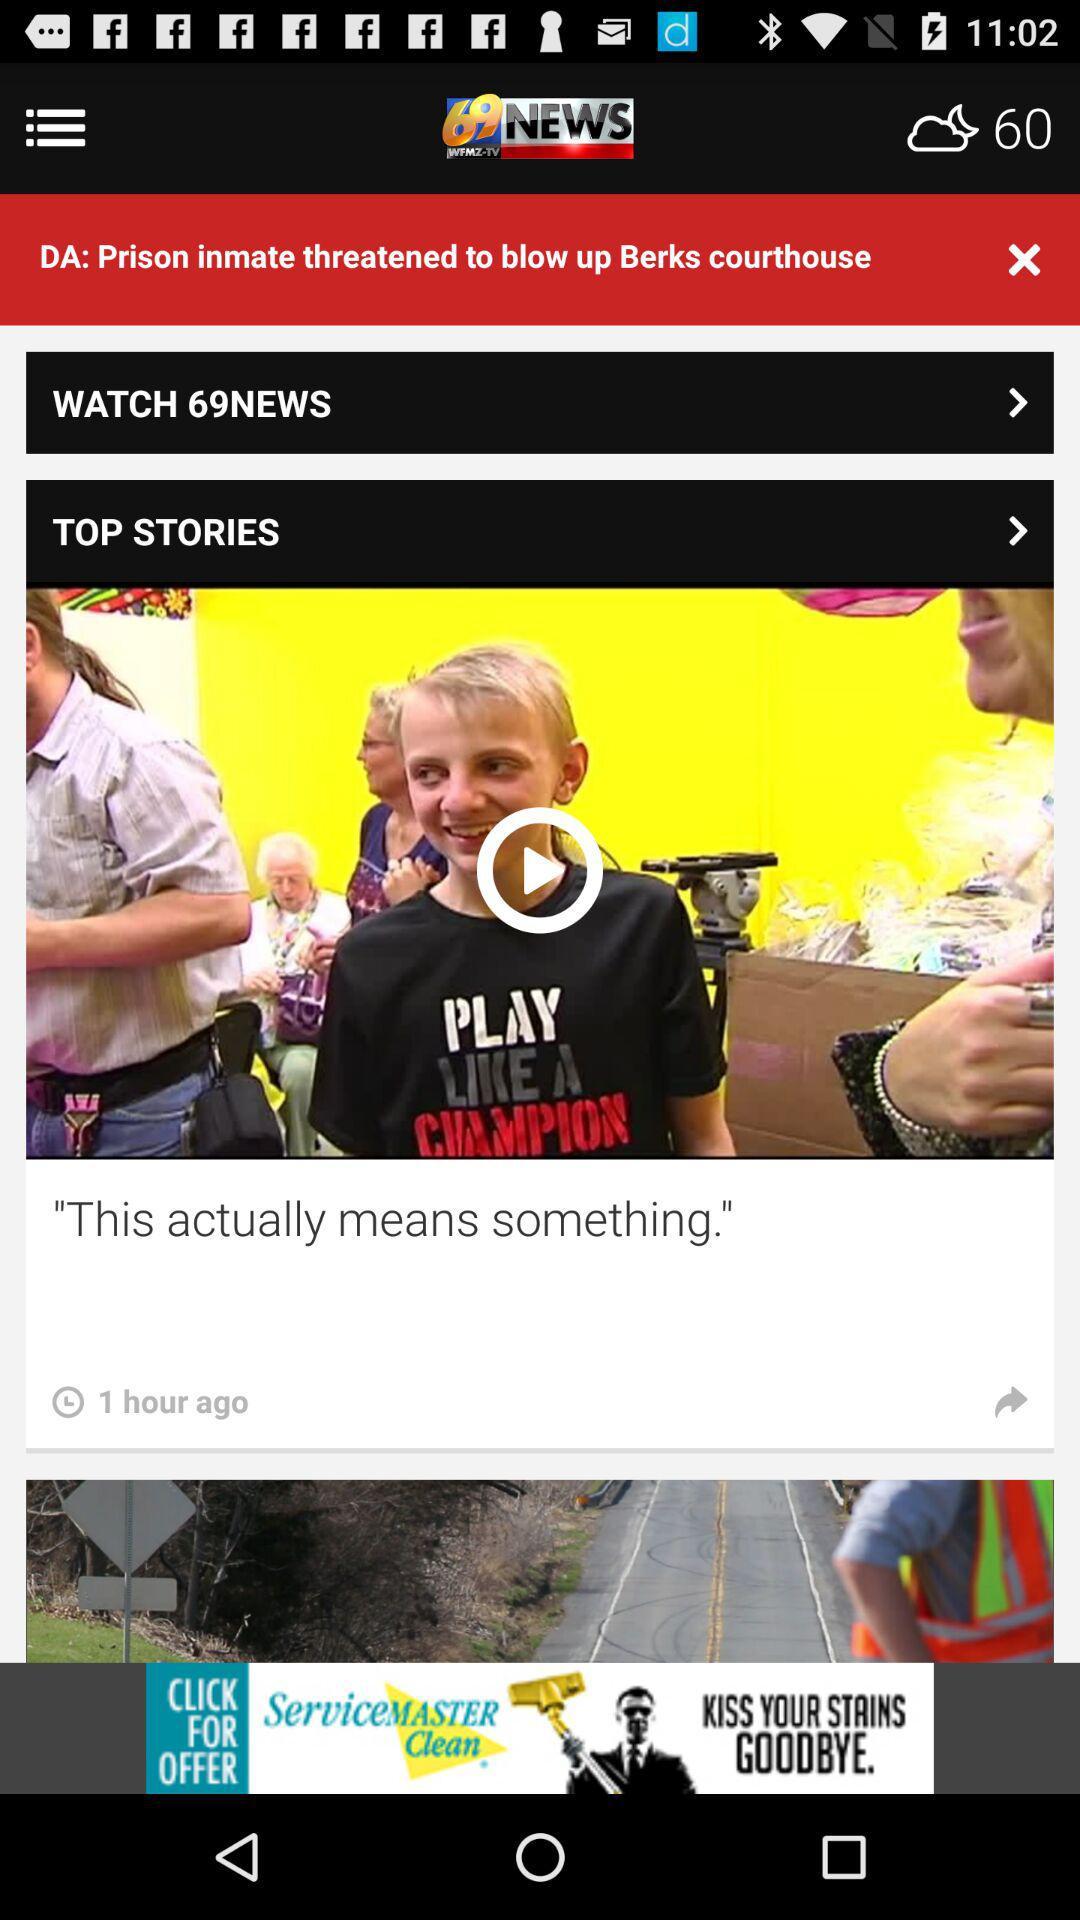What was the time of the post for the news "This actually means something"? The time of the post was 1 hour ago. 